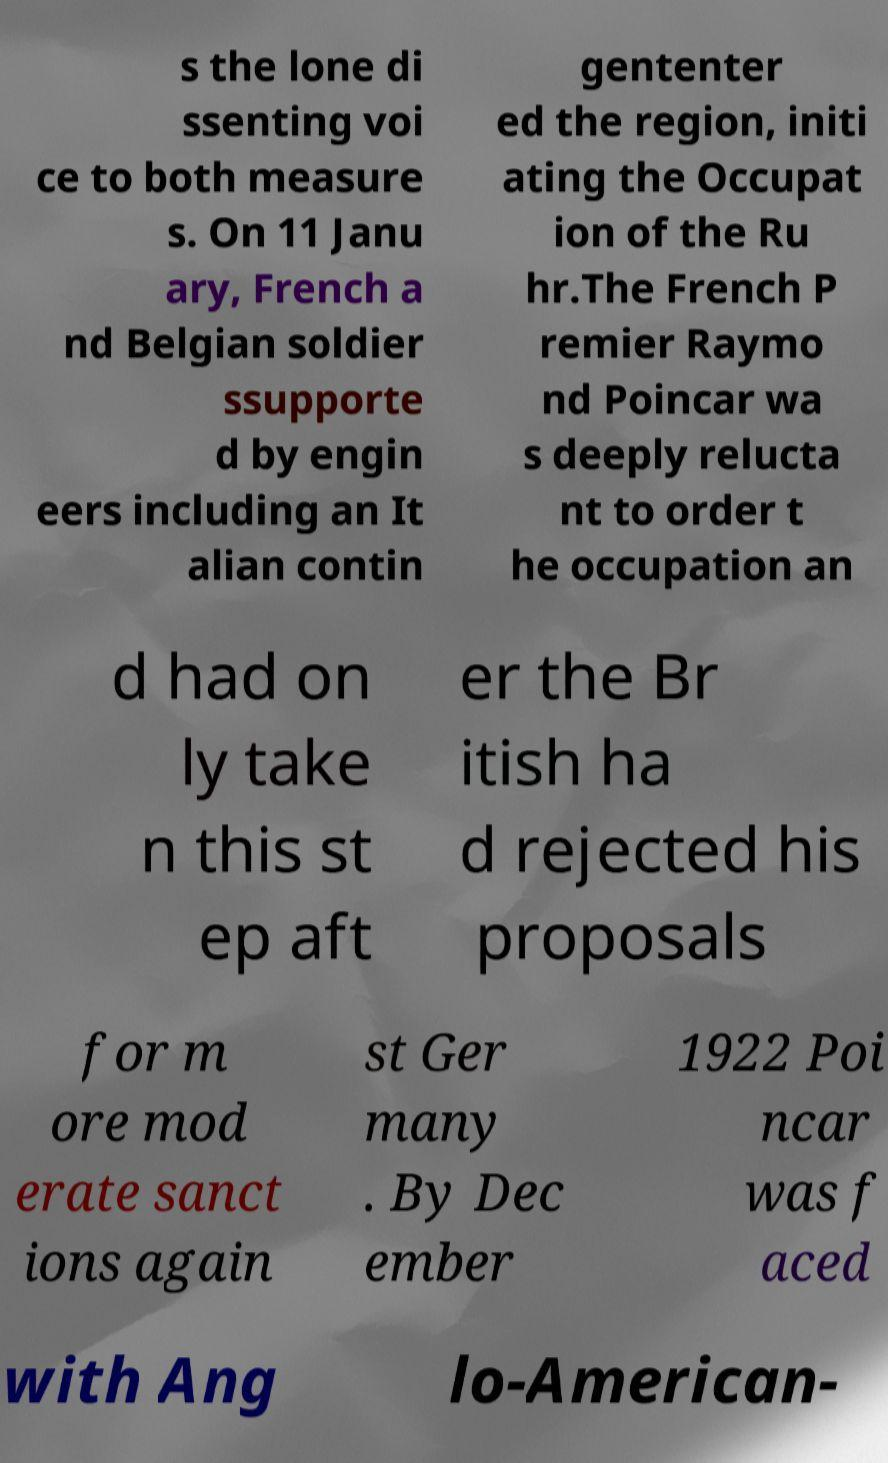Could you extract and type out the text from this image? s the lone di ssenting voi ce to both measure s. On 11 Janu ary, French a nd Belgian soldier ssupporte d by engin eers including an It alian contin gententer ed the region, initi ating the Occupat ion of the Ru hr.The French P remier Raymo nd Poincar wa s deeply relucta nt to order t he occupation an d had on ly take n this st ep aft er the Br itish ha d rejected his proposals for m ore mod erate sanct ions again st Ger many . By Dec ember 1922 Poi ncar was f aced with Ang lo-American- 